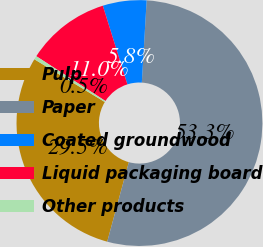Convert chart to OTSL. <chart><loc_0><loc_0><loc_500><loc_500><pie_chart><fcel>Pulp<fcel>Paper<fcel>Coated groundwood<fcel>Liquid packaging board<fcel>Other products<nl><fcel>29.46%<fcel>53.29%<fcel>5.75%<fcel>11.03%<fcel>0.47%<nl></chart> 